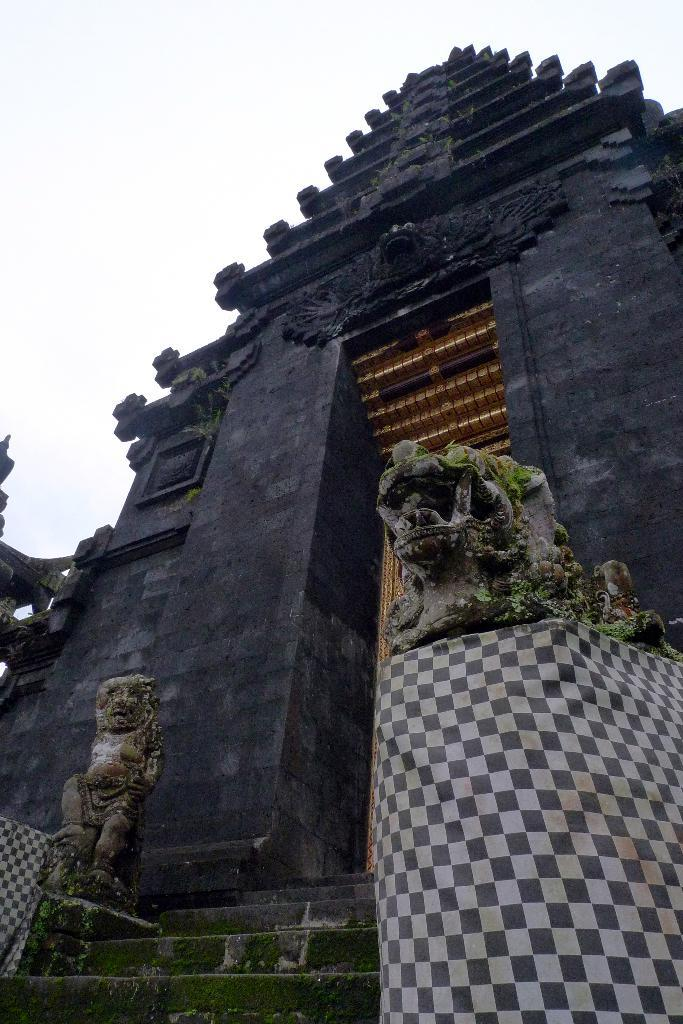What type of building is in the image? There is a temple in the image. What can be found on the temple? The temple has sculptures. What other figures are present in the image? There are statues in the image. What material is draped in the image? There is cloth visible in the image. How can one access the temple? There are stairs in the image. What is visible in the background of the image? The sky is visible in the image. Where are the objects located in the image? The objects are on the left side of the image. What type of cap is worn by the statue on the right side of the image? There is no statue on the right side of the image, and therefore no cap can be observed. 